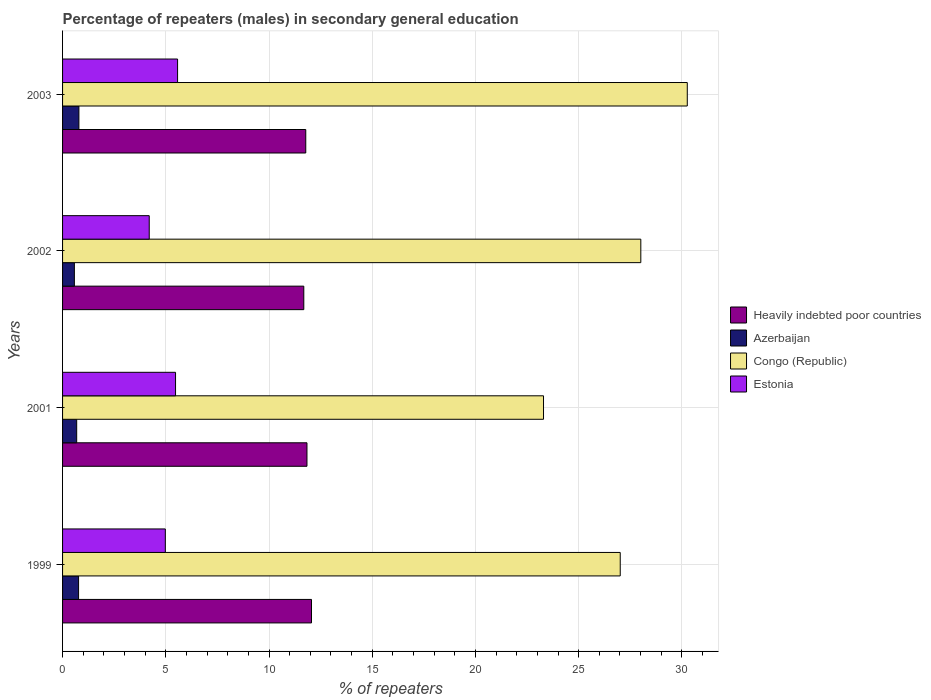How many different coloured bars are there?
Your answer should be very brief. 4. Are the number of bars per tick equal to the number of legend labels?
Offer a very short reply. Yes. Are the number of bars on each tick of the Y-axis equal?
Ensure brevity in your answer.  Yes. How many bars are there on the 4th tick from the top?
Make the answer very short. 4. How many bars are there on the 1st tick from the bottom?
Provide a succinct answer. 4. In how many cases, is the number of bars for a given year not equal to the number of legend labels?
Ensure brevity in your answer.  0. What is the percentage of male repeaters in Congo (Republic) in 1999?
Your response must be concise. 27.01. Across all years, what is the maximum percentage of male repeaters in Heavily indebted poor countries?
Ensure brevity in your answer.  12.06. Across all years, what is the minimum percentage of male repeaters in Heavily indebted poor countries?
Provide a short and direct response. 11.68. In which year was the percentage of male repeaters in Azerbaijan maximum?
Give a very brief answer. 2003. In which year was the percentage of male repeaters in Estonia minimum?
Offer a very short reply. 2002. What is the total percentage of male repeaters in Azerbaijan in the graph?
Keep it short and to the point. 2.82. What is the difference between the percentage of male repeaters in Congo (Republic) in 1999 and that in 2001?
Provide a short and direct response. 3.72. What is the difference between the percentage of male repeaters in Congo (Republic) in 1999 and the percentage of male repeaters in Estonia in 2002?
Provide a short and direct response. 22.81. What is the average percentage of male repeaters in Congo (Republic) per year?
Offer a very short reply. 27.14. In the year 2002, what is the difference between the percentage of male repeaters in Estonia and percentage of male repeaters in Congo (Republic)?
Keep it short and to the point. -23.81. In how many years, is the percentage of male repeaters in Congo (Republic) greater than 19 %?
Your response must be concise. 4. What is the ratio of the percentage of male repeaters in Heavily indebted poor countries in 1999 to that in 2002?
Your response must be concise. 1.03. Is the percentage of male repeaters in Heavily indebted poor countries in 2002 less than that in 2003?
Offer a terse response. Yes. Is the difference between the percentage of male repeaters in Estonia in 2001 and 2002 greater than the difference between the percentage of male repeaters in Congo (Republic) in 2001 and 2002?
Your response must be concise. Yes. What is the difference between the highest and the second highest percentage of male repeaters in Estonia?
Provide a succinct answer. 0.1. What is the difference between the highest and the lowest percentage of male repeaters in Heavily indebted poor countries?
Your answer should be very brief. 0.37. What does the 4th bar from the top in 1999 represents?
Your response must be concise. Heavily indebted poor countries. What does the 3rd bar from the bottom in 2003 represents?
Your answer should be very brief. Congo (Republic). Are all the bars in the graph horizontal?
Provide a succinct answer. Yes. What is the difference between two consecutive major ticks on the X-axis?
Make the answer very short. 5. Are the values on the major ticks of X-axis written in scientific E-notation?
Offer a very short reply. No. Does the graph contain any zero values?
Give a very brief answer. No. Where does the legend appear in the graph?
Your answer should be very brief. Center right. How are the legend labels stacked?
Provide a succinct answer. Vertical. What is the title of the graph?
Offer a very short reply. Percentage of repeaters (males) in secondary general education. Does "Libya" appear as one of the legend labels in the graph?
Provide a succinct answer. No. What is the label or title of the X-axis?
Keep it short and to the point. % of repeaters. What is the label or title of the Y-axis?
Your answer should be very brief. Years. What is the % of repeaters of Heavily indebted poor countries in 1999?
Offer a terse response. 12.06. What is the % of repeaters of Azerbaijan in 1999?
Provide a succinct answer. 0.78. What is the % of repeaters of Congo (Republic) in 1999?
Your response must be concise. 27.01. What is the % of repeaters in Estonia in 1999?
Keep it short and to the point. 4.98. What is the % of repeaters of Heavily indebted poor countries in 2001?
Your answer should be very brief. 11.84. What is the % of repeaters in Azerbaijan in 2001?
Your answer should be compact. 0.68. What is the % of repeaters of Congo (Republic) in 2001?
Offer a terse response. 23.3. What is the % of repeaters of Estonia in 2001?
Your response must be concise. 5.47. What is the % of repeaters in Heavily indebted poor countries in 2002?
Offer a very short reply. 11.68. What is the % of repeaters of Azerbaijan in 2002?
Keep it short and to the point. 0.57. What is the % of repeaters of Congo (Republic) in 2002?
Your answer should be compact. 28.01. What is the % of repeaters in Estonia in 2002?
Your response must be concise. 4.2. What is the % of repeaters of Heavily indebted poor countries in 2003?
Make the answer very short. 11.78. What is the % of repeaters of Azerbaijan in 2003?
Offer a terse response. 0.79. What is the % of repeaters in Congo (Republic) in 2003?
Provide a succinct answer. 30.26. What is the % of repeaters of Estonia in 2003?
Your answer should be very brief. 5.57. Across all years, what is the maximum % of repeaters in Heavily indebted poor countries?
Your response must be concise. 12.06. Across all years, what is the maximum % of repeaters in Azerbaijan?
Provide a short and direct response. 0.79. Across all years, what is the maximum % of repeaters in Congo (Republic)?
Provide a short and direct response. 30.26. Across all years, what is the maximum % of repeaters of Estonia?
Provide a succinct answer. 5.57. Across all years, what is the minimum % of repeaters in Heavily indebted poor countries?
Provide a succinct answer. 11.68. Across all years, what is the minimum % of repeaters of Azerbaijan?
Offer a terse response. 0.57. Across all years, what is the minimum % of repeaters in Congo (Republic)?
Ensure brevity in your answer.  23.3. Across all years, what is the minimum % of repeaters of Estonia?
Your response must be concise. 4.2. What is the total % of repeaters in Heavily indebted poor countries in the graph?
Make the answer very short. 47.36. What is the total % of repeaters in Azerbaijan in the graph?
Provide a succinct answer. 2.82. What is the total % of repeaters of Congo (Republic) in the graph?
Give a very brief answer. 108.58. What is the total % of repeaters in Estonia in the graph?
Offer a terse response. 20.22. What is the difference between the % of repeaters in Heavily indebted poor countries in 1999 and that in 2001?
Keep it short and to the point. 0.22. What is the difference between the % of repeaters of Azerbaijan in 1999 and that in 2001?
Your answer should be very brief. 0.09. What is the difference between the % of repeaters of Congo (Republic) in 1999 and that in 2001?
Keep it short and to the point. 3.72. What is the difference between the % of repeaters in Estonia in 1999 and that in 2001?
Offer a very short reply. -0.49. What is the difference between the % of repeaters in Heavily indebted poor countries in 1999 and that in 2002?
Offer a terse response. 0.37. What is the difference between the % of repeaters in Azerbaijan in 1999 and that in 2002?
Give a very brief answer. 0.2. What is the difference between the % of repeaters of Congo (Republic) in 1999 and that in 2002?
Your answer should be very brief. -1. What is the difference between the % of repeaters of Estonia in 1999 and that in 2002?
Provide a succinct answer. 0.78. What is the difference between the % of repeaters of Heavily indebted poor countries in 1999 and that in 2003?
Provide a succinct answer. 0.28. What is the difference between the % of repeaters of Azerbaijan in 1999 and that in 2003?
Your response must be concise. -0.02. What is the difference between the % of repeaters in Congo (Republic) in 1999 and that in 2003?
Offer a terse response. -3.25. What is the difference between the % of repeaters of Estonia in 1999 and that in 2003?
Offer a terse response. -0.59. What is the difference between the % of repeaters in Heavily indebted poor countries in 2001 and that in 2002?
Your answer should be very brief. 0.15. What is the difference between the % of repeaters of Azerbaijan in 2001 and that in 2002?
Give a very brief answer. 0.11. What is the difference between the % of repeaters of Congo (Republic) in 2001 and that in 2002?
Offer a very short reply. -4.71. What is the difference between the % of repeaters in Estonia in 2001 and that in 2002?
Keep it short and to the point. 1.27. What is the difference between the % of repeaters of Heavily indebted poor countries in 2001 and that in 2003?
Keep it short and to the point. 0.06. What is the difference between the % of repeaters in Azerbaijan in 2001 and that in 2003?
Ensure brevity in your answer.  -0.11. What is the difference between the % of repeaters in Congo (Republic) in 2001 and that in 2003?
Make the answer very short. -6.96. What is the difference between the % of repeaters in Estonia in 2001 and that in 2003?
Make the answer very short. -0.1. What is the difference between the % of repeaters in Heavily indebted poor countries in 2002 and that in 2003?
Keep it short and to the point. -0.1. What is the difference between the % of repeaters in Azerbaijan in 2002 and that in 2003?
Offer a terse response. -0.22. What is the difference between the % of repeaters in Congo (Republic) in 2002 and that in 2003?
Your answer should be compact. -2.25. What is the difference between the % of repeaters of Estonia in 2002 and that in 2003?
Your answer should be compact. -1.37. What is the difference between the % of repeaters in Heavily indebted poor countries in 1999 and the % of repeaters in Azerbaijan in 2001?
Ensure brevity in your answer.  11.37. What is the difference between the % of repeaters of Heavily indebted poor countries in 1999 and the % of repeaters of Congo (Republic) in 2001?
Provide a succinct answer. -11.24. What is the difference between the % of repeaters in Heavily indebted poor countries in 1999 and the % of repeaters in Estonia in 2001?
Your response must be concise. 6.59. What is the difference between the % of repeaters of Azerbaijan in 1999 and the % of repeaters of Congo (Republic) in 2001?
Provide a succinct answer. -22.52. What is the difference between the % of repeaters of Azerbaijan in 1999 and the % of repeaters of Estonia in 2001?
Provide a short and direct response. -4.7. What is the difference between the % of repeaters of Congo (Republic) in 1999 and the % of repeaters of Estonia in 2001?
Provide a succinct answer. 21.54. What is the difference between the % of repeaters of Heavily indebted poor countries in 1999 and the % of repeaters of Azerbaijan in 2002?
Keep it short and to the point. 11.49. What is the difference between the % of repeaters of Heavily indebted poor countries in 1999 and the % of repeaters of Congo (Republic) in 2002?
Offer a terse response. -15.95. What is the difference between the % of repeaters in Heavily indebted poor countries in 1999 and the % of repeaters in Estonia in 2002?
Give a very brief answer. 7.86. What is the difference between the % of repeaters of Azerbaijan in 1999 and the % of repeaters of Congo (Republic) in 2002?
Provide a succinct answer. -27.23. What is the difference between the % of repeaters in Azerbaijan in 1999 and the % of repeaters in Estonia in 2002?
Provide a succinct answer. -3.42. What is the difference between the % of repeaters in Congo (Republic) in 1999 and the % of repeaters in Estonia in 2002?
Give a very brief answer. 22.81. What is the difference between the % of repeaters in Heavily indebted poor countries in 1999 and the % of repeaters in Azerbaijan in 2003?
Your answer should be very brief. 11.27. What is the difference between the % of repeaters of Heavily indebted poor countries in 1999 and the % of repeaters of Congo (Republic) in 2003?
Offer a very short reply. -18.2. What is the difference between the % of repeaters in Heavily indebted poor countries in 1999 and the % of repeaters in Estonia in 2003?
Your answer should be compact. 6.49. What is the difference between the % of repeaters of Azerbaijan in 1999 and the % of repeaters of Congo (Republic) in 2003?
Offer a terse response. -29.48. What is the difference between the % of repeaters in Azerbaijan in 1999 and the % of repeaters in Estonia in 2003?
Your answer should be very brief. -4.8. What is the difference between the % of repeaters in Congo (Republic) in 1999 and the % of repeaters in Estonia in 2003?
Give a very brief answer. 21.44. What is the difference between the % of repeaters in Heavily indebted poor countries in 2001 and the % of repeaters in Azerbaijan in 2002?
Your answer should be compact. 11.27. What is the difference between the % of repeaters of Heavily indebted poor countries in 2001 and the % of repeaters of Congo (Republic) in 2002?
Provide a short and direct response. -16.17. What is the difference between the % of repeaters of Heavily indebted poor countries in 2001 and the % of repeaters of Estonia in 2002?
Provide a succinct answer. 7.64. What is the difference between the % of repeaters in Azerbaijan in 2001 and the % of repeaters in Congo (Republic) in 2002?
Your response must be concise. -27.33. What is the difference between the % of repeaters of Azerbaijan in 2001 and the % of repeaters of Estonia in 2002?
Offer a very short reply. -3.51. What is the difference between the % of repeaters in Congo (Republic) in 2001 and the % of repeaters in Estonia in 2002?
Provide a succinct answer. 19.1. What is the difference between the % of repeaters of Heavily indebted poor countries in 2001 and the % of repeaters of Azerbaijan in 2003?
Your answer should be compact. 11.05. What is the difference between the % of repeaters of Heavily indebted poor countries in 2001 and the % of repeaters of Congo (Republic) in 2003?
Offer a terse response. -18.42. What is the difference between the % of repeaters in Heavily indebted poor countries in 2001 and the % of repeaters in Estonia in 2003?
Keep it short and to the point. 6.27. What is the difference between the % of repeaters of Azerbaijan in 2001 and the % of repeaters of Congo (Republic) in 2003?
Your response must be concise. -29.58. What is the difference between the % of repeaters of Azerbaijan in 2001 and the % of repeaters of Estonia in 2003?
Offer a terse response. -4.89. What is the difference between the % of repeaters in Congo (Republic) in 2001 and the % of repeaters in Estonia in 2003?
Make the answer very short. 17.72. What is the difference between the % of repeaters of Heavily indebted poor countries in 2002 and the % of repeaters of Azerbaijan in 2003?
Keep it short and to the point. 10.89. What is the difference between the % of repeaters of Heavily indebted poor countries in 2002 and the % of repeaters of Congo (Republic) in 2003?
Give a very brief answer. -18.58. What is the difference between the % of repeaters in Heavily indebted poor countries in 2002 and the % of repeaters in Estonia in 2003?
Provide a short and direct response. 6.11. What is the difference between the % of repeaters of Azerbaijan in 2002 and the % of repeaters of Congo (Republic) in 2003?
Give a very brief answer. -29.69. What is the difference between the % of repeaters in Azerbaijan in 2002 and the % of repeaters in Estonia in 2003?
Ensure brevity in your answer.  -5. What is the difference between the % of repeaters in Congo (Republic) in 2002 and the % of repeaters in Estonia in 2003?
Offer a very short reply. 22.44. What is the average % of repeaters of Heavily indebted poor countries per year?
Your answer should be compact. 11.84. What is the average % of repeaters of Azerbaijan per year?
Provide a short and direct response. 0.71. What is the average % of repeaters in Congo (Republic) per year?
Offer a very short reply. 27.14. What is the average % of repeaters of Estonia per year?
Your answer should be very brief. 5.05. In the year 1999, what is the difference between the % of repeaters in Heavily indebted poor countries and % of repeaters in Azerbaijan?
Offer a terse response. 11.28. In the year 1999, what is the difference between the % of repeaters of Heavily indebted poor countries and % of repeaters of Congo (Republic)?
Offer a very short reply. -14.95. In the year 1999, what is the difference between the % of repeaters in Heavily indebted poor countries and % of repeaters in Estonia?
Your answer should be compact. 7.08. In the year 1999, what is the difference between the % of repeaters of Azerbaijan and % of repeaters of Congo (Republic)?
Offer a terse response. -26.24. In the year 1999, what is the difference between the % of repeaters of Azerbaijan and % of repeaters of Estonia?
Provide a short and direct response. -4.2. In the year 1999, what is the difference between the % of repeaters of Congo (Republic) and % of repeaters of Estonia?
Provide a short and direct response. 22.03. In the year 2001, what is the difference between the % of repeaters in Heavily indebted poor countries and % of repeaters in Azerbaijan?
Your response must be concise. 11.15. In the year 2001, what is the difference between the % of repeaters in Heavily indebted poor countries and % of repeaters in Congo (Republic)?
Offer a very short reply. -11.46. In the year 2001, what is the difference between the % of repeaters in Heavily indebted poor countries and % of repeaters in Estonia?
Your response must be concise. 6.37. In the year 2001, what is the difference between the % of repeaters of Azerbaijan and % of repeaters of Congo (Republic)?
Your answer should be very brief. -22.61. In the year 2001, what is the difference between the % of repeaters of Azerbaijan and % of repeaters of Estonia?
Offer a terse response. -4.79. In the year 2001, what is the difference between the % of repeaters of Congo (Republic) and % of repeaters of Estonia?
Make the answer very short. 17.82. In the year 2002, what is the difference between the % of repeaters in Heavily indebted poor countries and % of repeaters in Azerbaijan?
Ensure brevity in your answer.  11.11. In the year 2002, what is the difference between the % of repeaters in Heavily indebted poor countries and % of repeaters in Congo (Republic)?
Provide a succinct answer. -16.32. In the year 2002, what is the difference between the % of repeaters of Heavily indebted poor countries and % of repeaters of Estonia?
Your answer should be very brief. 7.49. In the year 2002, what is the difference between the % of repeaters of Azerbaijan and % of repeaters of Congo (Republic)?
Provide a short and direct response. -27.44. In the year 2002, what is the difference between the % of repeaters of Azerbaijan and % of repeaters of Estonia?
Offer a very short reply. -3.63. In the year 2002, what is the difference between the % of repeaters in Congo (Republic) and % of repeaters in Estonia?
Offer a very short reply. 23.81. In the year 2003, what is the difference between the % of repeaters in Heavily indebted poor countries and % of repeaters in Azerbaijan?
Offer a terse response. 10.99. In the year 2003, what is the difference between the % of repeaters in Heavily indebted poor countries and % of repeaters in Congo (Republic)?
Provide a succinct answer. -18.48. In the year 2003, what is the difference between the % of repeaters in Heavily indebted poor countries and % of repeaters in Estonia?
Offer a very short reply. 6.21. In the year 2003, what is the difference between the % of repeaters in Azerbaijan and % of repeaters in Congo (Republic)?
Offer a terse response. -29.47. In the year 2003, what is the difference between the % of repeaters in Azerbaijan and % of repeaters in Estonia?
Keep it short and to the point. -4.78. In the year 2003, what is the difference between the % of repeaters in Congo (Republic) and % of repeaters in Estonia?
Offer a very short reply. 24.69. What is the ratio of the % of repeaters of Heavily indebted poor countries in 1999 to that in 2001?
Give a very brief answer. 1.02. What is the ratio of the % of repeaters of Azerbaijan in 1999 to that in 2001?
Give a very brief answer. 1.13. What is the ratio of the % of repeaters of Congo (Republic) in 1999 to that in 2001?
Offer a very short reply. 1.16. What is the ratio of the % of repeaters of Estonia in 1999 to that in 2001?
Provide a short and direct response. 0.91. What is the ratio of the % of repeaters in Heavily indebted poor countries in 1999 to that in 2002?
Your answer should be compact. 1.03. What is the ratio of the % of repeaters in Azerbaijan in 1999 to that in 2002?
Your answer should be very brief. 1.36. What is the ratio of the % of repeaters in Congo (Republic) in 1999 to that in 2002?
Your answer should be very brief. 0.96. What is the ratio of the % of repeaters of Estonia in 1999 to that in 2002?
Make the answer very short. 1.19. What is the ratio of the % of repeaters in Heavily indebted poor countries in 1999 to that in 2003?
Keep it short and to the point. 1.02. What is the ratio of the % of repeaters of Azerbaijan in 1999 to that in 2003?
Provide a succinct answer. 0.98. What is the ratio of the % of repeaters of Congo (Republic) in 1999 to that in 2003?
Offer a terse response. 0.89. What is the ratio of the % of repeaters in Estonia in 1999 to that in 2003?
Offer a terse response. 0.89. What is the ratio of the % of repeaters in Heavily indebted poor countries in 2001 to that in 2002?
Provide a short and direct response. 1.01. What is the ratio of the % of repeaters in Azerbaijan in 2001 to that in 2002?
Give a very brief answer. 1.2. What is the ratio of the % of repeaters of Congo (Republic) in 2001 to that in 2002?
Provide a succinct answer. 0.83. What is the ratio of the % of repeaters in Estonia in 2001 to that in 2002?
Your answer should be compact. 1.3. What is the ratio of the % of repeaters of Azerbaijan in 2001 to that in 2003?
Your answer should be very brief. 0.86. What is the ratio of the % of repeaters of Congo (Republic) in 2001 to that in 2003?
Your response must be concise. 0.77. What is the ratio of the % of repeaters in Estonia in 2001 to that in 2003?
Your answer should be compact. 0.98. What is the ratio of the % of repeaters of Azerbaijan in 2002 to that in 2003?
Keep it short and to the point. 0.72. What is the ratio of the % of repeaters in Congo (Republic) in 2002 to that in 2003?
Provide a succinct answer. 0.93. What is the ratio of the % of repeaters in Estonia in 2002 to that in 2003?
Offer a terse response. 0.75. What is the difference between the highest and the second highest % of repeaters in Heavily indebted poor countries?
Ensure brevity in your answer.  0.22. What is the difference between the highest and the second highest % of repeaters of Azerbaijan?
Your answer should be very brief. 0.02. What is the difference between the highest and the second highest % of repeaters in Congo (Republic)?
Your response must be concise. 2.25. What is the difference between the highest and the second highest % of repeaters of Estonia?
Offer a very short reply. 0.1. What is the difference between the highest and the lowest % of repeaters in Heavily indebted poor countries?
Provide a short and direct response. 0.37. What is the difference between the highest and the lowest % of repeaters of Azerbaijan?
Your response must be concise. 0.22. What is the difference between the highest and the lowest % of repeaters of Congo (Republic)?
Offer a very short reply. 6.96. What is the difference between the highest and the lowest % of repeaters of Estonia?
Keep it short and to the point. 1.37. 